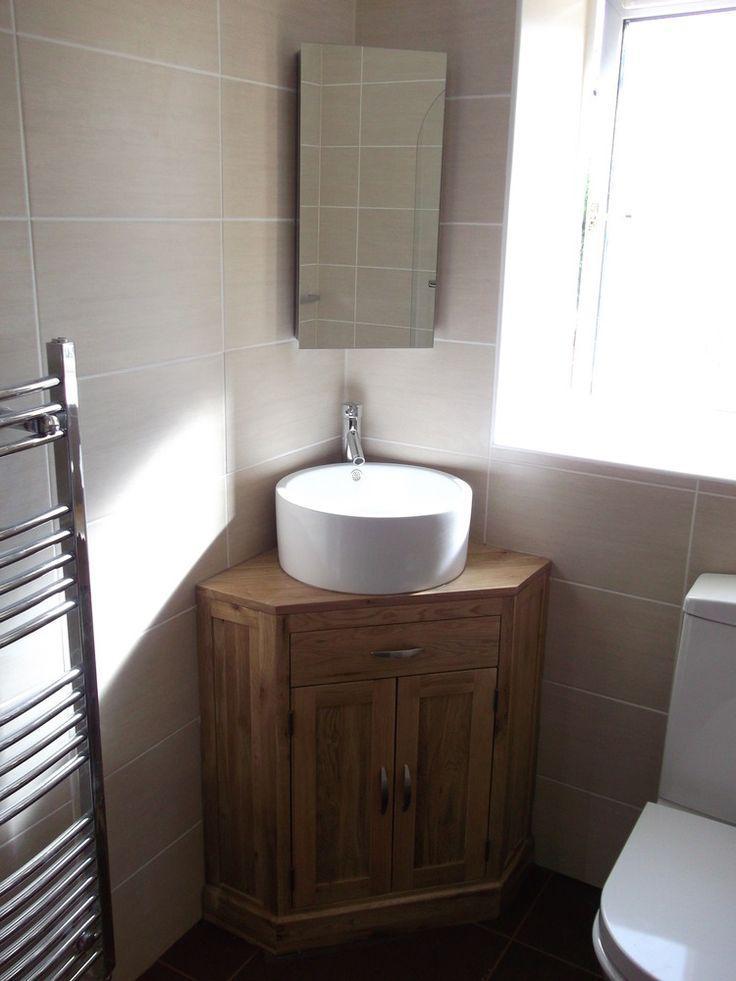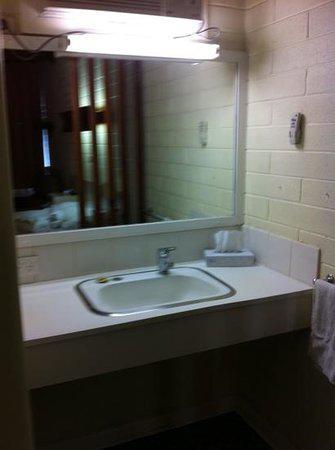The first image is the image on the left, the second image is the image on the right. Evaluate the accuracy of this statement regarding the images: "In at least one image there is a raised circle basin sink with a mirror behind it.". Is it true? Answer yes or no. Yes. 